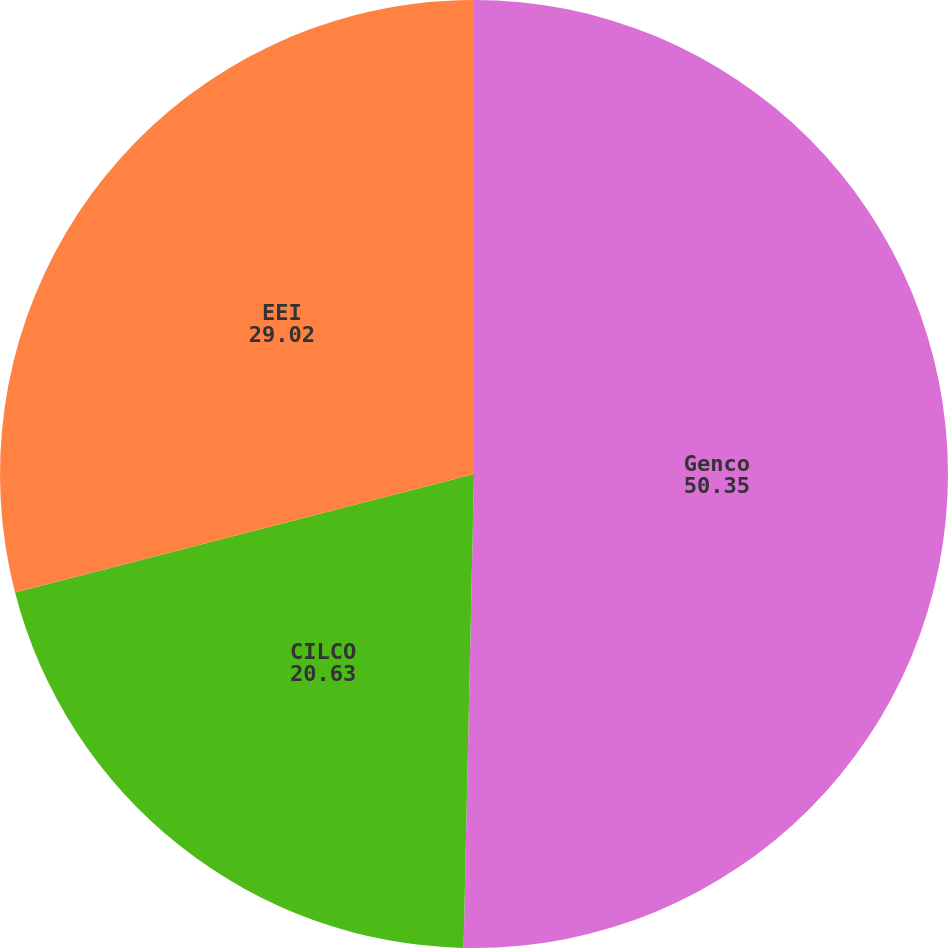Convert chart to OTSL. <chart><loc_0><loc_0><loc_500><loc_500><pie_chart><fcel>Genco<fcel>CILCO<fcel>EEI<nl><fcel>50.35%<fcel>20.63%<fcel>29.02%<nl></chart> 